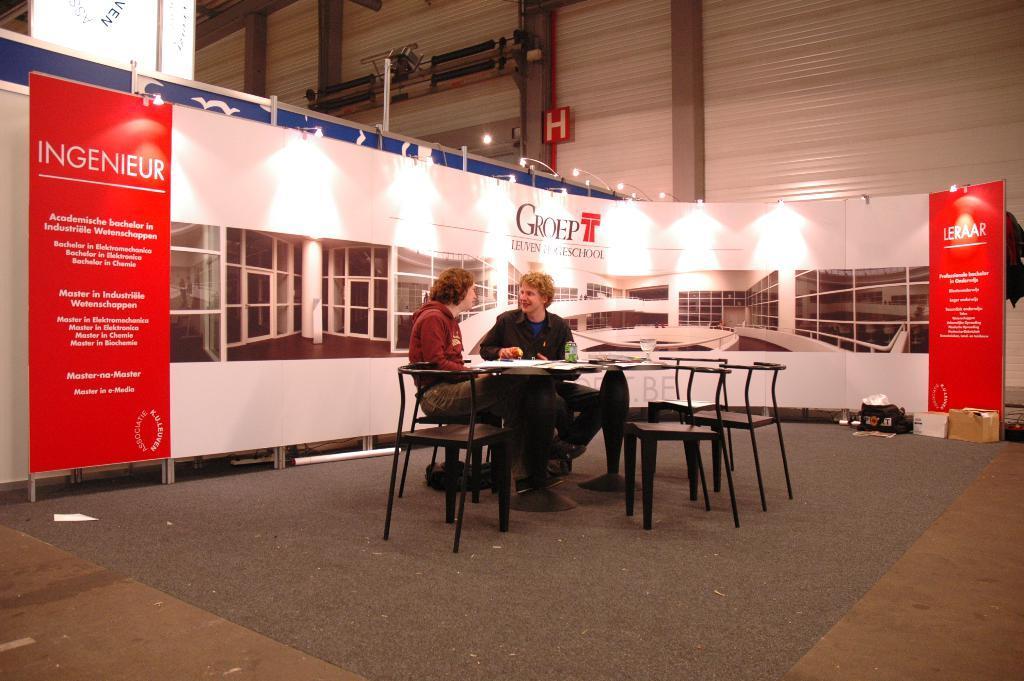Please provide a concise description of this image. This picture is consists of a table and the chairs around it, there is a girl and a boy, sitting at the center of the image and there are lights above the area of the image, and there are posters which are placed around the area of the image. 